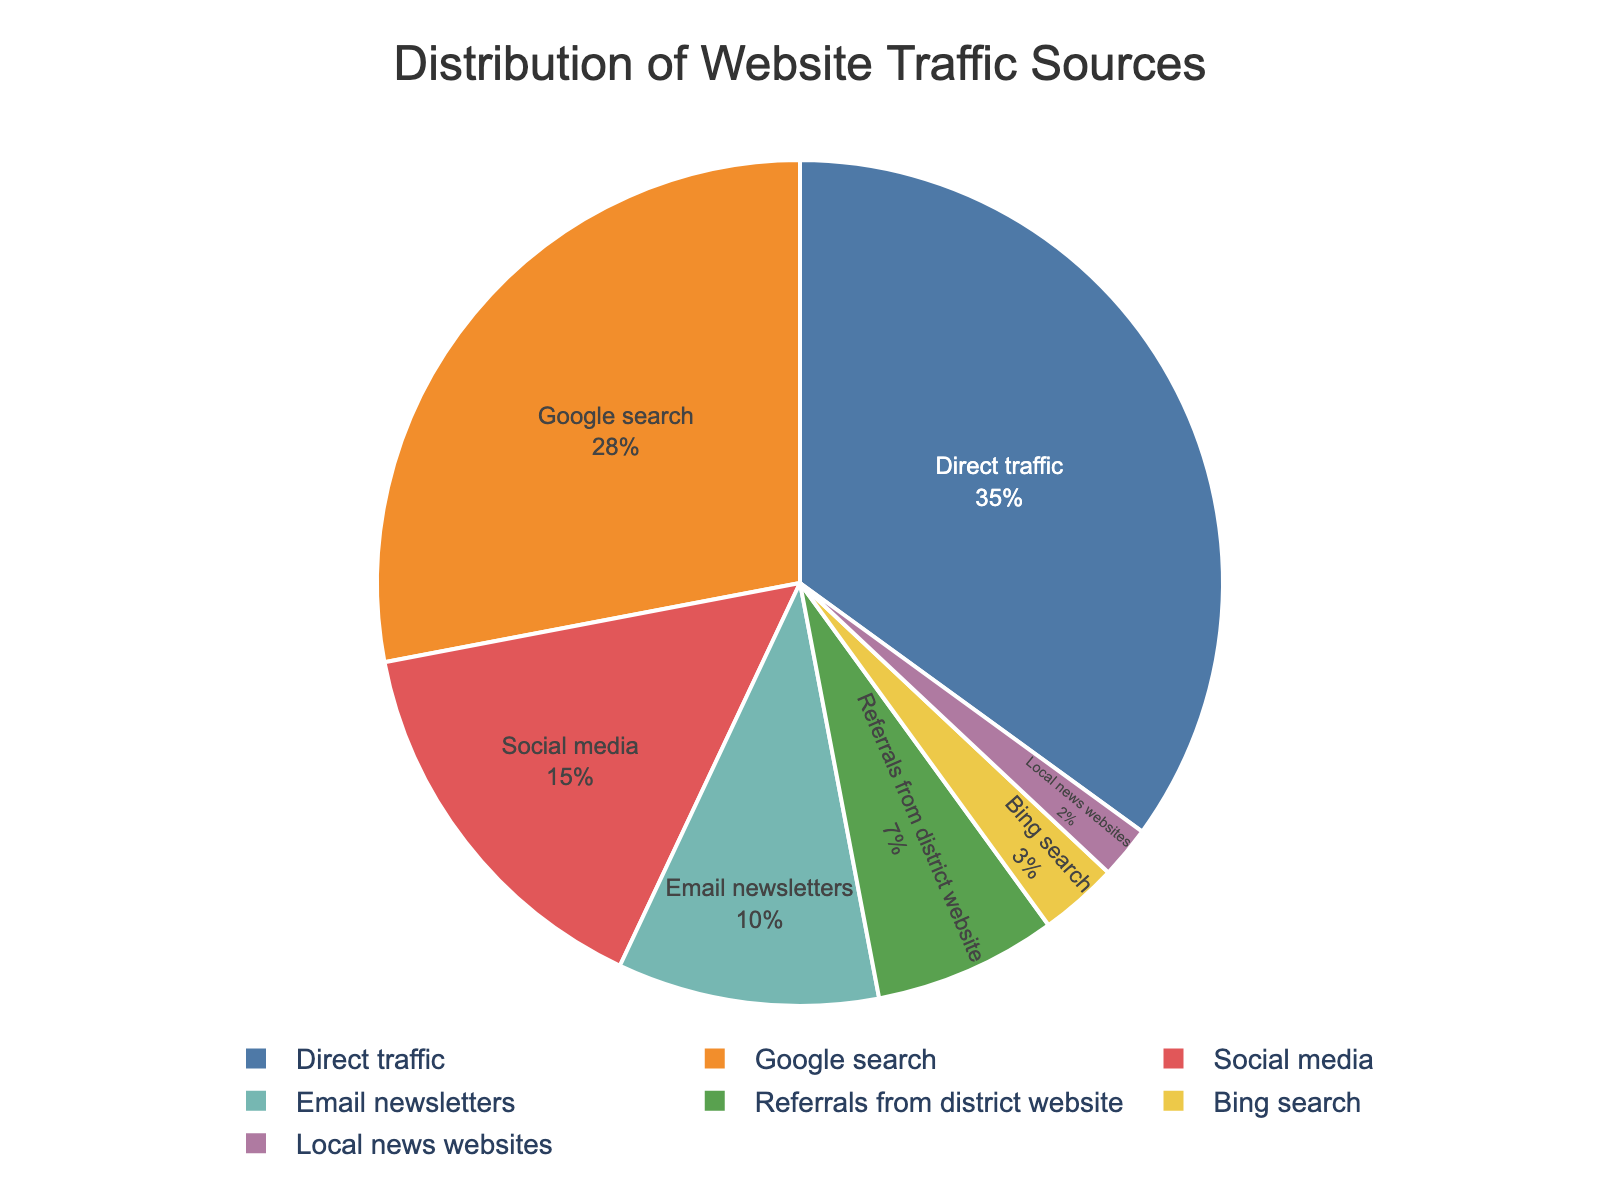Which traffic source contributes the most to the website? By looking at the sector of the pie chart that has the largest percentage, we see that "Direct traffic" takes up the largest portion.
Answer: Direct traffic What is the combined percentage of traffic from social media and email newsletters? Combine the percentages of "Social media" (15%) and "Email newsletters" (10%). This is 15% + 10% = 25%.
Answer: 25% How does the percentage of traffic from Google search compare to traffic from Bing search? The percentage of traffic from "Google search" is 28%, while from "Bing search" it is 3%. Compare these two percentages: 28% is much higher than 3%.
Answer: Google search is greater Which two traffic sources have the smallest contributions, and what is their combined percentage? Identify the two smallest sectors in the pie chart which are "Local news websites" (2%) and "Bing search" (3%). Combine their percentages: 2% + 3% = 5%.
Answer: Local news websites and Bing search, 5% What is the total percentage of traffic coming from external sources (all sources except Direct traffic)? Exclude "Direct traffic" (35%) and sum the percentages of the other sources: 28% + 15% + 10% + 7% + 3% + 2% = 65%.
Answer: 65% Does Direct traffic contribute more than the total combined of Social media and Referrals from district website? Compare "Direct traffic" (35%) with the sum of "Social media" (15%) and "Referrals from district website" (7%) = 15% + 7% = 22%. 35% is greater than 22%.
Answer: Yes What percentage of traffic is not from search engines (Google and Bing)? Sum the percentages of all non-search engine sources: Direct traffic (35%) + Social media (15%) + Email newsletters (10%) + Referrals from district website (7%) + Local news websites (2%) = 35% + 15% + 10% + 7% + 2% = 69%.
Answer: 69% Which source has a visually distinctive green color and what percentage does it represent? Look at the segment of the pie chart colored green, which corresponds to "Social media" with a 15% contribution.
Answer: Social media, 15% How does traffic from Referrals from district website compare to traffic from Email newsletters? Refer to their individual percentages: "Referrals from district website" (7%) and "Email newsletters" (10%). Compare these percentages: 7% is less than 10%.
Answer: Referrals from district website is less If we grouped traffic sources into Search engines (Google and Bing) and Others, what would be the percentage for each group? Combine the percentages of search engines (Google search 28% and Bing search 3%), which is 28% + 3% = 31%, and combine the percentages of others, which is 100% - 31% = 69%.
Answer: Search engines 31%, Others 69% 